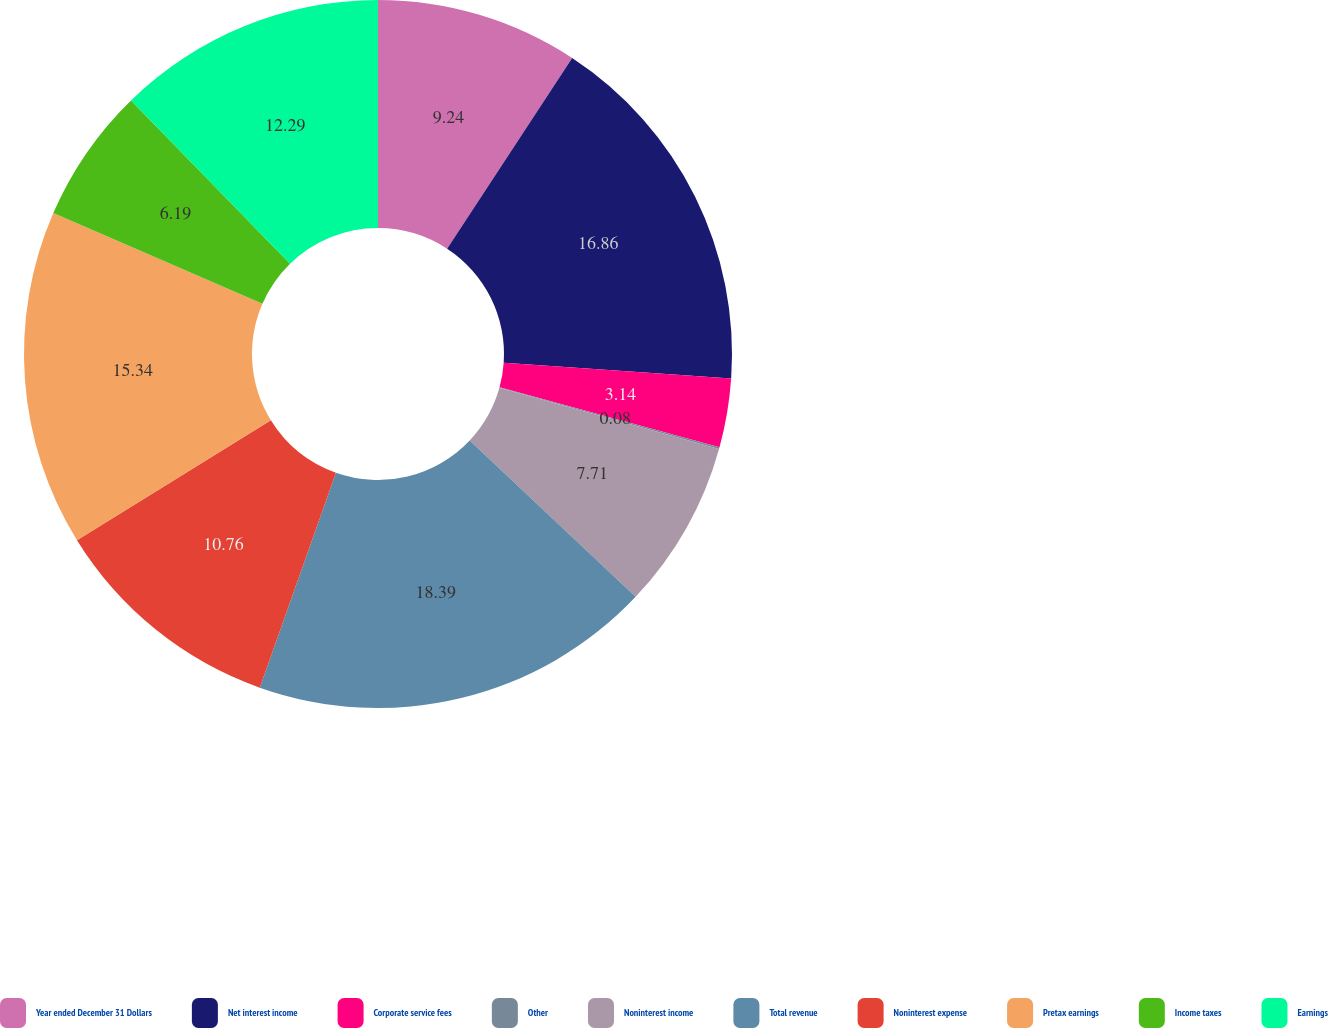Convert chart to OTSL. <chart><loc_0><loc_0><loc_500><loc_500><pie_chart><fcel>Year ended December 31 Dollars<fcel>Net interest income<fcel>Corporate service fees<fcel>Other<fcel>Noninterest income<fcel>Total revenue<fcel>Noninterest expense<fcel>Pretax earnings<fcel>Income taxes<fcel>Earnings<nl><fcel>9.24%<fcel>16.86%<fcel>3.14%<fcel>0.08%<fcel>7.71%<fcel>18.39%<fcel>10.76%<fcel>15.34%<fcel>6.19%<fcel>12.29%<nl></chart> 